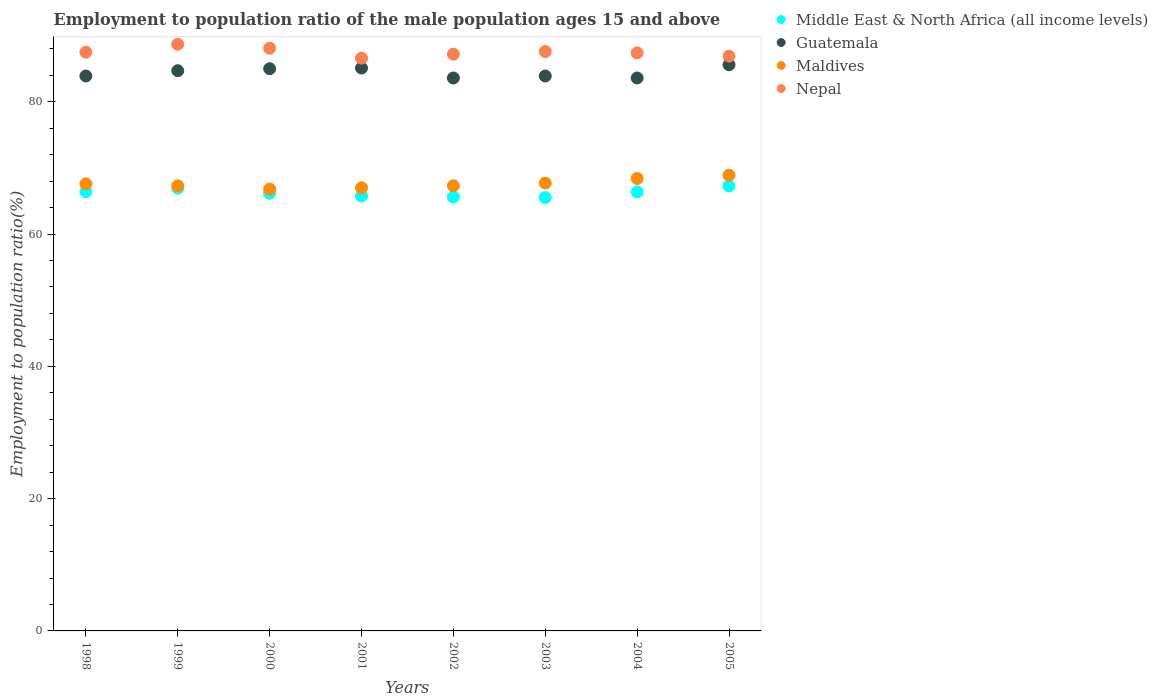Is the number of dotlines equal to the number of legend labels?
Your answer should be compact. Yes. What is the employment to population ratio in Maldives in 2002?
Offer a very short reply. 67.3. Across all years, what is the maximum employment to population ratio in Guatemala?
Offer a very short reply. 85.6. Across all years, what is the minimum employment to population ratio in Nepal?
Give a very brief answer. 86.6. What is the total employment to population ratio in Guatemala in the graph?
Your answer should be compact. 675.4. What is the difference between the employment to population ratio in Middle East & North Africa (all income levels) in 1998 and that in 2000?
Provide a succinct answer. 0.22. What is the difference between the employment to population ratio in Nepal in 2004 and the employment to population ratio in Maldives in 2002?
Offer a terse response. 20.1. What is the average employment to population ratio in Guatemala per year?
Your answer should be compact. 84.42. In the year 2001, what is the difference between the employment to population ratio in Nepal and employment to population ratio in Guatemala?
Your response must be concise. 1.5. In how many years, is the employment to population ratio in Guatemala greater than 4 %?
Ensure brevity in your answer.  8. What is the ratio of the employment to population ratio in Nepal in 2000 to that in 2002?
Provide a succinct answer. 1.01. Is the difference between the employment to population ratio in Nepal in 2000 and 2002 greater than the difference between the employment to population ratio in Guatemala in 2000 and 2002?
Your answer should be very brief. No. What is the difference between the highest and the second highest employment to population ratio in Maldives?
Provide a short and direct response. 0.5. What is the difference between the highest and the lowest employment to population ratio in Middle East & North Africa (all income levels)?
Give a very brief answer. 1.75. Is the sum of the employment to population ratio in Guatemala in 1998 and 1999 greater than the maximum employment to population ratio in Nepal across all years?
Give a very brief answer. Yes. Is it the case that in every year, the sum of the employment to population ratio in Guatemala and employment to population ratio in Middle East & North Africa (all income levels)  is greater than the sum of employment to population ratio in Nepal and employment to population ratio in Maldives?
Offer a terse response. No. Is the employment to population ratio in Middle East & North Africa (all income levels) strictly greater than the employment to population ratio in Nepal over the years?
Your answer should be very brief. No. How many dotlines are there?
Your answer should be very brief. 4. Are the values on the major ticks of Y-axis written in scientific E-notation?
Give a very brief answer. No. Does the graph contain grids?
Offer a terse response. No. How many legend labels are there?
Provide a short and direct response. 4. What is the title of the graph?
Your answer should be compact. Employment to population ratio of the male population ages 15 and above. What is the label or title of the Y-axis?
Give a very brief answer. Employment to population ratio(%). What is the Employment to population ratio(%) of Middle East & North Africa (all income levels) in 1998?
Keep it short and to the point. 66.39. What is the Employment to population ratio(%) of Guatemala in 1998?
Provide a short and direct response. 83.9. What is the Employment to population ratio(%) of Maldives in 1998?
Provide a short and direct response. 67.6. What is the Employment to population ratio(%) of Nepal in 1998?
Make the answer very short. 87.5. What is the Employment to population ratio(%) of Middle East & North Africa (all income levels) in 1999?
Offer a terse response. 66.94. What is the Employment to population ratio(%) of Guatemala in 1999?
Provide a short and direct response. 84.7. What is the Employment to population ratio(%) in Maldives in 1999?
Provide a short and direct response. 67.3. What is the Employment to population ratio(%) in Nepal in 1999?
Your response must be concise. 88.7. What is the Employment to population ratio(%) in Middle East & North Africa (all income levels) in 2000?
Provide a short and direct response. 66.17. What is the Employment to population ratio(%) in Maldives in 2000?
Your response must be concise. 66.8. What is the Employment to population ratio(%) in Nepal in 2000?
Make the answer very short. 88.1. What is the Employment to population ratio(%) in Middle East & North Africa (all income levels) in 2001?
Keep it short and to the point. 65.75. What is the Employment to population ratio(%) in Guatemala in 2001?
Offer a very short reply. 85.1. What is the Employment to population ratio(%) in Maldives in 2001?
Your answer should be very brief. 67. What is the Employment to population ratio(%) in Nepal in 2001?
Ensure brevity in your answer.  86.6. What is the Employment to population ratio(%) of Middle East & North Africa (all income levels) in 2002?
Keep it short and to the point. 65.6. What is the Employment to population ratio(%) of Guatemala in 2002?
Keep it short and to the point. 83.6. What is the Employment to population ratio(%) in Maldives in 2002?
Your answer should be compact. 67.3. What is the Employment to population ratio(%) of Nepal in 2002?
Offer a very short reply. 87.2. What is the Employment to population ratio(%) in Middle East & North Africa (all income levels) in 2003?
Offer a very short reply. 65.53. What is the Employment to population ratio(%) of Guatemala in 2003?
Your answer should be compact. 83.9. What is the Employment to population ratio(%) in Maldives in 2003?
Keep it short and to the point. 67.7. What is the Employment to population ratio(%) in Nepal in 2003?
Offer a very short reply. 87.6. What is the Employment to population ratio(%) in Middle East & North Africa (all income levels) in 2004?
Provide a short and direct response. 66.37. What is the Employment to population ratio(%) of Guatemala in 2004?
Offer a very short reply. 83.6. What is the Employment to population ratio(%) of Maldives in 2004?
Provide a succinct answer. 68.4. What is the Employment to population ratio(%) in Nepal in 2004?
Your response must be concise. 87.4. What is the Employment to population ratio(%) of Middle East & North Africa (all income levels) in 2005?
Offer a terse response. 67.28. What is the Employment to population ratio(%) of Guatemala in 2005?
Your response must be concise. 85.6. What is the Employment to population ratio(%) of Maldives in 2005?
Make the answer very short. 68.9. What is the Employment to population ratio(%) in Nepal in 2005?
Your response must be concise. 86.9. Across all years, what is the maximum Employment to population ratio(%) in Middle East & North Africa (all income levels)?
Provide a short and direct response. 67.28. Across all years, what is the maximum Employment to population ratio(%) in Guatemala?
Provide a short and direct response. 85.6. Across all years, what is the maximum Employment to population ratio(%) of Maldives?
Provide a succinct answer. 68.9. Across all years, what is the maximum Employment to population ratio(%) in Nepal?
Provide a succinct answer. 88.7. Across all years, what is the minimum Employment to population ratio(%) in Middle East & North Africa (all income levels)?
Provide a succinct answer. 65.53. Across all years, what is the minimum Employment to population ratio(%) in Guatemala?
Your response must be concise. 83.6. Across all years, what is the minimum Employment to population ratio(%) of Maldives?
Ensure brevity in your answer.  66.8. Across all years, what is the minimum Employment to population ratio(%) in Nepal?
Keep it short and to the point. 86.6. What is the total Employment to population ratio(%) in Middle East & North Africa (all income levels) in the graph?
Ensure brevity in your answer.  530.03. What is the total Employment to population ratio(%) in Guatemala in the graph?
Provide a short and direct response. 675.4. What is the total Employment to population ratio(%) of Maldives in the graph?
Ensure brevity in your answer.  541. What is the total Employment to population ratio(%) in Nepal in the graph?
Keep it short and to the point. 700. What is the difference between the Employment to population ratio(%) of Middle East & North Africa (all income levels) in 1998 and that in 1999?
Your answer should be very brief. -0.54. What is the difference between the Employment to population ratio(%) of Guatemala in 1998 and that in 1999?
Keep it short and to the point. -0.8. What is the difference between the Employment to population ratio(%) of Maldives in 1998 and that in 1999?
Keep it short and to the point. 0.3. What is the difference between the Employment to population ratio(%) in Middle East & North Africa (all income levels) in 1998 and that in 2000?
Your answer should be compact. 0.22. What is the difference between the Employment to population ratio(%) of Guatemala in 1998 and that in 2000?
Provide a short and direct response. -1.1. What is the difference between the Employment to population ratio(%) in Middle East & North Africa (all income levels) in 1998 and that in 2001?
Provide a short and direct response. 0.64. What is the difference between the Employment to population ratio(%) in Middle East & North Africa (all income levels) in 1998 and that in 2002?
Ensure brevity in your answer.  0.79. What is the difference between the Employment to population ratio(%) of Nepal in 1998 and that in 2002?
Your answer should be very brief. 0.3. What is the difference between the Employment to population ratio(%) of Middle East & North Africa (all income levels) in 1998 and that in 2003?
Offer a very short reply. 0.86. What is the difference between the Employment to population ratio(%) in Maldives in 1998 and that in 2003?
Offer a terse response. -0.1. What is the difference between the Employment to population ratio(%) in Nepal in 1998 and that in 2003?
Your answer should be compact. -0.1. What is the difference between the Employment to population ratio(%) of Middle East & North Africa (all income levels) in 1998 and that in 2004?
Offer a terse response. 0.03. What is the difference between the Employment to population ratio(%) in Maldives in 1998 and that in 2004?
Give a very brief answer. -0.8. What is the difference between the Employment to population ratio(%) in Nepal in 1998 and that in 2004?
Keep it short and to the point. 0.1. What is the difference between the Employment to population ratio(%) in Middle East & North Africa (all income levels) in 1998 and that in 2005?
Provide a short and direct response. -0.89. What is the difference between the Employment to population ratio(%) in Maldives in 1998 and that in 2005?
Provide a short and direct response. -1.3. What is the difference between the Employment to population ratio(%) of Nepal in 1998 and that in 2005?
Your answer should be very brief. 0.6. What is the difference between the Employment to population ratio(%) in Middle East & North Africa (all income levels) in 1999 and that in 2000?
Your answer should be compact. 0.77. What is the difference between the Employment to population ratio(%) in Middle East & North Africa (all income levels) in 1999 and that in 2001?
Provide a succinct answer. 1.18. What is the difference between the Employment to population ratio(%) in Nepal in 1999 and that in 2001?
Your response must be concise. 2.1. What is the difference between the Employment to population ratio(%) in Middle East & North Africa (all income levels) in 1999 and that in 2002?
Offer a very short reply. 1.33. What is the difference between the Employment to population ratio(%) in Guatemala in 1999 and that in 2002?
Ensure brevity in your answer.  1.1. What is the difference between the Employment to population ratio(%) in Middle East & North Africa (all income levels) in 1999 and that in 2003?
Your answer should be compact. 1.41. What is the difference between the Employment to population ratio(%) of Middle East & North Africa (all income levels) in 1999 and that in 2004?
Your response must be concise. 0.57. What is the difference between the Employment to population ratio(%) of Guatemala in 1999 and that in 2004?
Offer a very short reply. 1.1. What is the difference between the Employment to population ratio(%) of Maldives in 1999 and that in 2004?
Your answer should be compact. -1.1. What is the difference between the Employment to population ratio(%) in Nepal in 1999 and that in 2004?
Offer a terse response. 1.3. What is the difference between the Employment to population ratio(%) in Middle East & North Africa (all income levels) in 1999 and that in 2005?
Your response must be concise. -0.34. What is the difference between the Employment to population ratio(%) of Guatemala in 1999 and that in 2005?
Give a very brief answer. -0.9. What is the difference between the Employment to population ratio(%) in Maldives in 1999 and that in 2005?
Your response must be concise. -1.6. What is the difference between the Employment to population ratio(%) in Nepal in 1999 and that in 2005?
Provide a succinct answer. 1.8. What is the difference between the Employment to population ratio(%) in Middle East & North Africa (all income levels) in 2000 and that in 2001?
Keep it short and to the point. 0.41. What is the difference between the Employment to population ratio(%) of Nepal in 2000 and that in 2001?
Ensure brevity in your answer.  1.5. What is the difference between the Employment to population ratio(%) of Middle East & North Africa (all income levels) in 2000 and that in 2002?
Provide a short and direct response. 0.56. What is the difference between the Employment to population ratio(%) in Middle East & North Africa (all income levels) in 2000 and that in 2003?
Provide a short and direct response. 0.64. What is the difference between the Employment to population ratio(%) in Guatemala in 2000 and that in 2003?
Ensure brevity in your answer.  1.1. What is the difference between the Employment to population ratio(%) of Maldives in 2000 and that in 2003?
Make the answer very short. -0.9. What is the difference between the Employment to population ratio(%) of Middle East & North Africa (all income levels) in 2000 and that in 2004?
Give a very brief answer. -0.2. What is the difference between the Employment to population ratio(%) of Guatemala in 2000 and that in 2004?
Your answer should be compact. 1.4. What is the difference between the Employment to population ratio(%) of Maldives in 2000 and that in 2004?
Provide a short and direct response. -1.6. What is the difference between the Employment to population ratio(%) of Nepal in 2000 and that in 2004?
Your response must be concise. 0.7. What is the difference between the Employment to population ratio(%) in Middle East & North Africa (all income levels) in 2000 and that in 2005?
Offer a very short reply. -1.11. What is the difference between the Employment to population ratio(%) in Nepal in 2000 and that in 2005?
Offer a terse response. 1.2. What is the difference between the Employment to population ratio(%) of Middle East & North Africa (all income levels) in 2001 and that in 2002?
Ensure brevity in your answer.  0.15. What is the difference between the Employment to population ratio(%) of Maldives in 2001 and that in 2002?
Provide a succinct answer. -0.3. What is the difference between the Employment to population ratio(%) of Nepal in 2001 and that in 2002?
Keep it short and to the point. -0.6. What is the difference between the Employment to population ratio(%) of Middle East & North Africa (all income levels) in 2001 and that in 2003?
Make the answer very short. 0.22. What is the difference between the Employment to population ratio(%) of Guatemala in 2001 and that in 2003?
Offer a terse response. 1.2. What is the difference between the Employment to population ratio(%) of Nepal in 2001 and that in 2003?
Your answer should be compact. -1. What is the difference between the Employment to population ratio(%) in Middle East & North Africa (all income levels) in 2001 and that in 2004?
Offer a terse response. -0.61. What is the difference between the Employment to population ratio(%) of Guatemala in 2001 and that in 2004?
Provide a succinct answer. 1.5. What is the difference between the Employment to population ratio(%) of Nepal in 2001 and that in 2004?
Your answer should be compact. -0.8. What is the difference between the Employment to population ratio(%) in Middle East & North Africa (all income levels) in 2001 and that in 2005?
Give a very brief answer. -1.53. What is the difference between the Employment to population ratio(%) in Maldives in 2001 and that in 2005?
Offer a terse response. -1.9. What is the difference between the Employment to population ratio(%) of Middle East & North Africa (all income levels) in 2002 and that in 2003?
Ensure brevity in your answer.  0.08. What is the difference between the Employment to population ratio(%) in Middle East & North Africa (all income levels) in 2002 and that in 2004?
Ensure brevity in your answer.  -0.76. What is the difference between the Employment to population ratio(%) in Maldives in 2002 and that in 2004?
Keep it short and to the point. -1.1. What is the difference between the Employment to population ratio(%) in Nepal in 2002 and that in 2004?
Provide a succinct answer. -0.2. What is the difference between the Employment to population ratio(%) of Middle East & North Africa (all income levels) in 2002 and that in 2005?
Ensure brevity in your answer.  -1.67. What is the difference between the Employment to population ratio(%) in Guatemala in 2002 and that in 2005?
Offer a terse response. -2. What is the difference between the Employment to population ratio(%) of Middle East & North Africa (all income levels) in 2003 and that in 2004?
Keep it short and to the point. -0.84. What is the difference between the Employment to population ratio(%) in Middle East & North Africa (all income levels) in 2003 and that in 2005?
Provide a succinct answer. -1.75. What is the difference between the Employment to population ratio(%) in Guatemala in 2003 and that in 2005?
Give a very brief answer. -1.7. What is the difference between the Employment to population ratio(%) in Nepal in 2003 and that in 2005?
Provide a short and direct response. 0.7. What is the difference between the Employment to population ratio(%) in Middle East & North Africa (all income levels) in 2004 and that in 2005?
Your answer should be very brief. -0.91. What is the difference between the Employment to population ratio(%) of Guatemala in 2004 and that in 2005?
Offer a terse response. -2. What is the difference between the Employment to population ratio(%) in Maldives in 2004 and that in 2005?
Offer a terse response. -0.5. What is the difference between the Employment to population ratio(%) of Middle East & North Africa (all income levels) in 1998 and the Employment to population ratio(%) of Guatemala in 1999?
Ensure brevity in your answer.  -18.31. What is the difference between the Employment to population ratio(%) in Middle East & North Africa (all income levels) in 1998 and the Employment to population ratio(%) in Maldives in 1999?
Ensure brevity in your answer.  -0.91. What is the difference between the Employment to population ratio(%) in Middle East & North Africa (all income levels) in 1998 and the Employment to population ratio(%) in Nepal in 1999?
Offer a very short reply. -22.31. What is the difference between the Employment to population ratio(%) of Guatemala in 1998 and the Employment to population ratio(%) of Maldives in 1999?
Provide a short and direct response. 16.6. What is the difference between the Employment to population ratio(%) of Maldives in 1998 and the Employment to population ratio(%) of Nepal in 1999?
Make the answer very short. -21.1. What is the difference between the Employment to population ratio(%) in Middle East & North Africa (all income levels) in 1998 and the Employment to population ratio(%) in Guatemala in 2000?
Offer a terse response. -18.61. What is the difference between the Employment to population ratio(%) in Middle East & North Africa (all income levels) in 1998 and the Employment to population ratio(%) in Maldives in 2000?
Your answer should be compact. -0.41. What is the difference between the Employment to population ratio(%) in Middle East & North Africa (all income levels) in 1998 and the Employment to population ratio(%) in Nepal in 2000?
Provide a short and direct response. -21.71. What is the difference between the Employment to population ratio(%) in Guatemala in 1998 and the Employment to population ratio(%) in Maldives in 2000?
Provide a succinct answer. 17.1. What is the difference between the Employment to population ratio(%) in Guatemala in 1998 and the Employment to population ratio(%) in Nepal in 2000?
Provide a succinct answer. -4.2. What is the difference between the Employment to population ratio(%) of Maldives in 1998 and the Employment to population ratio(%) of Nepal in 2000?
Offer a terse response. -20.5. What is the difference between the Employment to population ratio(%) in Middle East & North Africa (all income levels) in 1998 and the Employment to population ratio(%) in Guatemala in 2001?
Keep it short and to the point. -18.71. What is the difference between the Employment to population ratio(%) in Middle East & North Africa (all income levels) in 1998 and the Employment to population ratio(%) in Maldives in 2001?
Provide a short and direct response. -0.61. What is the difference between the Employment to population ratio(%) in Middle East & North Africa (all income levels) in 1998 and the Employment to population ratio(%) in Nepal in 2001?
Make the answer very short. -20.21. What is the difference between the Employment to population ratio(%) of Middle East & North Africa (all income levels) in 1998 and the Employment to population ratio(%) of Guatemala in 2002?
Offer a very short reply. -17.21. What is the difference between the Employment to population ratio(%) in Middle East & North Africa (all income levels) in 1998 and the Employment to population ratio(%) in Maldives in 2002?
Offer a very short reply. -0.91. What is the difference between the Employment to population ratio(%) in Middle East & North Africa (all income levels) in 1998 and the Employment to population ratio(%) in Nepal in 2002?
Your answer should be very brief. -20.81. What is the difference between the Employment to population ratio(%) in Guatemala in 1998 and the Employment to population ratio(%) in Maldives in 2002?
Offer a very short reply. 16.6. What is the difference between the Employment to population ratio(%) in Guatemala in 1998 and the Employment to population ratio(%) in Nepal in 2002?
Provide a succinct answer. -3.3. What is the difference between the Employment to population ratio(%) of Maldives in 1998 and the Employment to population ratio(%) of Nepal in 2002?
Make the answer very short. -19.6. What is the difference between the Employment to population ratio(%) of Middle East & North Africa (all income levels) in 1998 and the Employment to population ratio(%) of Guatemala in 2003?
Keep it short and to the point. -17.51. What is the difference between the Employment to population ratio(%) of Middle East & North Africa (all income levels) in 1998 and the Employment to population ratio(%) of Maldives in 2003?
Your answer should be very brief. -1.31. What is the difference between the Employment to population ratio(%) in Middle East & North Africa (all income levels) in 1998 and the Employment to population ratio(%) in Nepal in 2003?
Give a very brief answer. -21.21. What is the difference between the Employment to population ratio(%) in Guatemala in 1998 and the Employment to population ratio(%) in Maldives in 2003?
Your response must be concise. 16.2. What is the difference between the Employment to population ratio(%) of Maldives in 1998 and the Employment to population ratio(%) of Nepal in 2003?
Provide a succinct answer. -20. What is the difference between the Employment to population ratio(%) of Middle East & North Africa (all income levels) in 1998 and the Employment to population ratio(%) of Guatemala in 2004?
Make the answer very short. -17.21. What is the difference between the Employment to population ratio(%) in Middle East & North Africa (all income levels) in 1998 and the Employment to population ratio(%) in Maldives in 2004?
Make the answer very short. -2.01. What is the difference between the Employment to population ratio(%) in Middle East & North Africa (all income levels) in 1998 and the Employment to population ratio(%) in Nepal in 2004?
Your response must be concise. -21.01. What is the difference between the Employment to population ratio(%) of Maldives in 1998 and the Employment to population ratio(%) of Nepal in 2004?
Your response must be concise. -19.8. What is the difference between the Employment to population ratio(%) in Middle East & North Africa (all income levels) in 1998 and the Employment to population ratio(%) in Guatemala in 2005?
Keep it short and to the point. -19.21. What is the difference between the Employment to population ratio(%) of Middle East & North Africa (all income levels) in 1998 and the Employment to population ratio(%) of Maldives in 2005?
Provide a succinct answer. -2.51. What is the difference between the Employment to population ratio(%) in Middle East & North Africa (all income levels) in 1998 and the Employment to population ratio(%) in Nepal in 2005?
Keep it short and to the point. -20.51. What is the difference between the Employment to population ratio(%) of Guatemala in 1998 and the Employment to population ratio(%) of Maldives in 2005?
Offer a very short reply. 15. What is the difference between the Employment to population ratio(%) in Maldives in 1998 and the Employment to population ratio(%) in Nepal in 2005?
Provide a short and direct response. -19.3. What is the difference between the Employment to population ratio(%) in Middle East & North Africa (all income levels) in 1999 and the Employment to population ratio(%) in Guatemala in 2000?
Your response must be concise. -18.06. What is the difference between the Employment to population ratio(%) in Middle East & North Africa (all income levels) in 1999 and the Employment to population ratio(%) in Maldives in 2000?
Ensure brevity in your answer.  0.14. What is the difference between the Employment to population ratio(%) in Middle East & North Africa (all income levels) in 1999 and the Employment to population ratio(%) in Nepal in 2000?
Give a very brief answer. -21.16. What is the difference between the Employment to population ratio(%) in Guatemala in 1999 and the Employment to population ratio(%) in Nepal in 2000?
Provide a short and direct response. -3.4. What is the difference between the Employment to population ratio(%) of Maldives in 1999 and the Employment to population ratio(%) of Nepal in 2000?
Your response must be concise. -20.8. What is the difference between the Employment to population ratio(%) of Middle East & North Africa (all income levels) in 1999 and the Employment to population ratio(%) of Guatemala in 2001?
Your response must be concise. -18.16. What is the difference between the Employment to population ratio(%) in Middle East & North Africa (all income levels) in 1999 and the Employment to population ratio(%) in Maldives in 2001?
Your answer should be very brief. -0.06. What is the difference between the Employment to population ratio(%) of Middle East & North Africa (all income levels) in 1999 and the Employment to population ratio(%) of Nepal in 2001?
Ensure brevity in your answer.  -19.66. What is the difference between the Employment to population ratio(%) of Guatemala in 1999 and the Employment to population ratio(%) of Nepal in 2001?
Your answer should be very brief. -1.9. What is the difference between the Employment to population ratio(%) of Maldives in 1999 and the Employment to population ratio(%) of Nepal in 2001?
Your answer should be very brief. -19.3. What is the difference between the Employment to population ratio(%) of Middle East & North Africa (all income levels) in 1999 and the Employment to population ratio(%) of Guatemala in 2002?
Your response must be concise. -16.66. What is the difference between the Employment to population ratio(%) of Middle East & North Africa (all income levels) in 1999 and the Employment to population ratio(%) of Maldives in 2002?
Your answer should be compact. -0.36. What is the difference between the Employment to population ratio(%) of Middle East & North Africa (all income levels) in 1999 and the Employment to population ratio(%) of Nepal in 2002?
Keep it short and to the point. -20.26. What is the difference between the Employment to population ratio(%) of Guatemala in 1999 and the Employment to population ratio(%) of Maldives in 2002?
Your response must be concise. 17.4. What is the difference between the Employment to population ratio(%) of Maldives in 1999 and the Employment to population ratio(%) of Nepal in 2002?
Keep it short and to the point. -19.9. What is the difference between the Employment to population ratio(%) in Middle East & North Africa (all income levels) in 1999 and the Employment to population ratio(%) in Guatemala in 2003?
Provide a short and direct response. -16.96. What is the difference between the Employment to population ratio(%) of Middle East & North Africa (all income levels) in 1999 and the Employment to population ratio(%) of Maldives in 2003?
Your response must be concise. -0.76. What is the difference between the Employment to population ratio(%) in Middle East & North Africa (all income levels) in 1999 and the Employment to population ratio(%) in Nepal in 2003?
Your answer should be compact. -20.66. What is the difference between the Employment to population ratio(%) in Guatemala in 1999 and the Employment to population ratio(%) in Maldives in 2003?
Ensure brevity in your answer.  17. What is the difference between the Employment to population ratio(%) of Guatemala in 1999 and the Employment to population ratio(%) of Nepal in 2003?
Provide a short and direct response. -2.9. What is the difference between the Employment to population ratio(%) of Maldives in 1999 and the Employment to population ratio(%) of Nepal in 2003?
Ensure brevity in your answer.  -20.3. What is the difference between the Employment to population ratio(%) of Middle East & North Africa (all income levels) in 1999 and the Employment to population ratio(%) of Guatemala in 2004?
Offer a terse response. -16.66. What is the difference between the Employment to population ratio(%) in Middle East & North Africa (all income levels) in 1999 and the Employment to population ratio(%) in Maldives in 2004?
Give a very brief answer. -1.46. What is the difference between the Employment to population ratio(%) of Middle East & North Africa (all income levels) in 1999 and the Employment to population ratio(%) of Nepal in 2004?
Ensure brevity in your answer.  -20.46. What is the difference between the Employment to population ratio(%) of Guatemala in 1999 and the Employment to population ratio(%) of Nepal in 2004?
Ensure brevity in your answer.  -2.7. What is the difference between the Employment to population ratio(%) of Maldives in 1999 and the Employment to population ratio(%) of Nepal in 2004?
Provide a succinct answer. -20.1. What is the difference between the Employment to population ratio(%) of Middle East & North Africa (all income levels) in 1999 and the Employment to population ratio(%) of Guatemala in 2005?
Provide a short and direct response. -18.66. What is the difference between the Employment to population ratio(%) of Middle East & North Africa (all income levels) in 1999 and the Employment to population ratio(%) of Maldives in 2005?
Make the answer very short. -1.96. What is the difference between the Employment to population ratio(%) in Middle East & North Africa (all income levels) in 1999 and the Employment to population ratio(%) in Nepal in 2005?
Offer a very short reply. -19.96. What is the difference between the Employment to population ratio(%) in Guatemala in 1999 and the Employment to population ratio(%) in Nepal in 2005?
Your answer should be compact. -2.2. What is the difference between the Employment to population ratio(%) in Maldives in 1999 and the Employment to population ratio(%) in Nepal in 2005?
Make the answer very short. -19.6. What is the difference between the Employment to population ratio(%) in Middle East & North Africa (all income levels) in 2000 and the Employment to population ratio(%) in Guatemala in 2001?
Ensure brevity in your answer.  -18.93. What is the difference between the Employment to population ratio(%) of Middle East & North Africa (all income levels) in 2000 and the Employment to population ratio(%) of Maldives in 2001?
Offer a very short reply. -0.83. What is the difference between the Employment to population ratio(%) in Middle East & North Africa (all income levels) in 2000 and the Employment to population ratio(%) in Nepal in 2001?
Make the answer very short. -20.43. What is the difference between the Employment to population ratio(%) in Guatemala in 2000 and the Employment to population ratio(%) in Maldives in 2001?
Provide a succinct answer. 18. What is the difference between the Employment to population ratio(%) in Guatemala in 2000 and the Employment to population ratio(%) in Nepal in 2001?
Make the answer very short. -1.6. What is the difference between the Employment to population ratio(%) in Maldives in 2000 and the Employment to population ratio(%) in Nepal in 2001?
Your response must be concise. -19.8. What is the difference between the Employment to population ratio(%) of Middle East & North Africa (all income levels) in 2000 and the Employment to population ratio(%) of Guatemala in 2002?
Your answer should be very brief. -17.43. What is the difference between the Employment to population ratio(%) of Middle East & North Africa (all income levels) in 2000 and the Employment to population ratio(%) of Maldives in 2002?
Your response must be concise. -1.13. What is the difference between the Employment to population ratio(%) of Middle East & North Africa (all income levels) in 2000 and the Employment to population ratio(%) of Nepal in 2002?
Offer a terse response. -21.03. What is the difference between the Employment to population ratio(%) of Guatemala in 2000 and the Employment to population ratio(%) of Maldives in 2002?
Your response must be concise. 17.7. What is the difference between the Employment to population ratio(%) of Maldives in 2000 and the Employment to population ratio(%) of Nepal in 2002?
Give a very brief answer. -20.4. What is the difference between the Employment to population ratio(%) of Middle East & North Africa (all income levels) in 2000 and the Employment to population ratio(%) of Guatemala in 2003?
Offer a very short reply. -17.73. What is the difference between the Employment to population ratio(%) in Middle East & North Africa (all income levels) in 2000 and the Employment to population ratio(%) in Maldives in 2003?
Keep it short and to the point. -1.53. What is the difference between the Employment to population ratio(%) of Middle East & North Africa (all income levels) in 2000 and the Employment to population ratio(%) of Nepal in 2003?
Your answer should be very brief. -21.43. What is the difference between the Employment to population ratio(%) in Guatemala in 2000 and the Employment to population ratio(%) in Maldives in 2003?
Provide a succinct answer. 17.3. What is the difference between the Employment to population ratio(%) of Maldives in 2000 and the Employment to population ratio(%) of Nepal in 2003?
Make the answer very short. -20.8. What is the difference between the Employment to population ratio(%) of Middle East & North Africa (all income levels) in 2000 and the Employment to population ratio(%) of Guatemala in 2004?
Provide a short and direct response. -17.43. What is the difference between the Employment to population ratio(%) in Middle East & North Africa (all income levels) in 2000 and the Employment to population ratio(%) in Maldives in 2004?
Your answer should be compact. -2.23. What is the difference between the Employment to population ratio(%) of Middle East & North Africa (all income levels) in 2000 and the Employment to population ratio(%) of Nepal in 2004?
Offer a terse response. -21.23. What is the difference between the Employment to population ratio(%) of Guatemala in 2000 and the Employment to population ratio(%) of Maldives in 2004?
Give a very brief answer. 16.6. What is the difference between the Employment to population ratio(%) in Guatemala in 2000 and the Employment to population ratio(%) in Nepal in 2004?
Provide a succinct answer. -2.4. What is the difference between the Employment to population ratio(%) of Maldives in 2000 and the Employment to population ratio(%) of Nepal in 2004?
Your answer should be very brief. -20.6. What is the difference between the Employment to population ratio(%) in Middle East & North Africa (all income levels) in 2000 and the Employment to population ratio(%) in Guatemala in 2005?
Ensure brevity in your answer.  -19.43. What is the difference between the Employment to population ratio(%) of Middle East & North Africa (all income levels) in 2000 and the Employment to population ratio(%) of Maldives in 2005?
Provide a succinct answer. -2.73. What is the difference between the Employment to population ratio(%) of Middle East & North Africa (all income levels) in 2000 and the Employment to population ratio(%) of Nepal in 2005?
Ensure brevity in your answer.  -20.73. What is the difference between the Employment to population ratio(%) of Maldives in 2000 and the Employment to population ratio(%) of Nepal in 2005?
Give a very brief answer. -20.1. What is the difference between the Employment to population ratio(%) of Middle East & North Africa (all income levels) in 2001 and the Employment to population ratio(%) of Guatemala in 2002?
Make the answer very short. -17.85. What is the difference between the Employment to population ratio(%) of Middle East & North Africa (all income levels) in 2001 and the Employment to population ratio(%) of Maldives in 2002?
Provide a short and direct response. -1.55. What is the difference between the Employment to population ratio(%) of Middle East & North Africa (all income levels) in 2001 and the Employment to population ratio(%) of Nepal in 2002?
Your answer should be very brief. -21.45. What is the difference between the Employment to population ratio(%) in Guatemala in 2001 and the Employment to population ratio(%) in Maldives in 2002?
Keep it short and to the point. 17.8. What is the difference between the Employment to population ratio(%) in Maldives in 2001 and the Employment to population ratio(%) in Nepal in 2002?
Provide a succinct answer. -20.2. What is the difference between the Employment to population ratio(%) in Middle East & North Africa (all income levels) in 2001 and the Employment to population ratio(%) in Guatemala in 2003?
Your answer should be compact. -18.15. What is the difference between the Employment to population ratio(%) in Middle East & North Africa (all income levels) in 2001 and the Employment to population ratio(%) in Maldives in 2003?
Offer a terse response. -1.95. What is the difference between the Employment to population ratio(%) in Middle East & North Africa (all income levels) in 2001 and the Employment to population ratio(%) in Nepal in 2003?
Keep it short and to the point. -21.85. What is the difference between the Employment to population ratio(%) of Maldives in 2001 and the Employment to population ratio(%) of Nepal in 2003?
Ensure brevity in your answer.  -20.6. What is the difference between the Employment to population ratio(%) of Middle East & North Africa (all income levels) in 2001 and the Employment to population ratio(%) of Guatemala in 2004?
Your answer should be very brief. -17.85. What is the difference between the Employment to population ratio(%) in Middle East & North Africa (all income levels) in 2001 and the Employment to population ratio(%) in Maldives in 2004?
Ensure brevity in your answer.  -2.65. What is the difference between the Employment to population ratio(%) of Middle East & North Africa (all income levels) in 2001 and the Employment to population ratio(%) of Nepal in 2004?
Provide a succinct answer. -21.65. What is the difference between the Employment to population ratio(%) of Guatemala in 2001 and the Employment to population ratio(%) of Maldives in 2004?
Ensure brevity in your answer.  16.7. What is the difference between the Employment to population ratio(%) in Guatemala in 2001 and the Employment to population ratio(%) in Nepal in 2004?
Offer a very short reply. -2.3. What is the difference between the Employment to population ratio(%) of Maldives in 2001 and the Employment to population ratio(%) of Nepal in 2004?
Your answer should be compact. -20.4. What is the difference between the Employment to population ratio(%) in Middle East & North Africa (all income levels) in 2001 and the Employment to population ratio(%) in Guatemala in 2005?
Provide a short and direct response. -19.85. What is the difference between the Employment to population ratio(%) of Middle East & North Africa (all income levels) in 2001 and the Employment to population ratio(%) of Maldives in 2005?
Your response must be concise. -3.15. What is the difference between the Employment to population ratio(%) of Middle East & North Africa (all income levels) in 2001 and the Employment to population ratio(%) of Nepal in 2005?
Provide a succinct answer. -21.15. What is the difference between the Employment to population ratio(%) of Guatemala in 2001 and the Employment to population ratio(%) of Maldives in 2005?
Provide a short and direct response. 16.2. What is the difference between the Employment to population ratio(%) in Maldives in 2001 and the Employment to population ratio(%) in Nepal in 2005?
Provide a succinct answer. -19.9. What is the difference between the Employment to population ratio(%) in Middle East & North Africa (all income levels) in 2002 and the Employment to population ratio(%) in Guatemala in 2003?
Offer a very short reply. -18.3. What is the difference between the Employment to population ratio(%) in Middle East & North Africa (all income levels) in 2002 and the Employment to population ratio(%) in Maldives in 2003?
Provide a short and direct response. -2.1. What is the difference between the Employment to population ratio(%) in Middle East & North Africa (all income levels) in 2002 and the Employment to population ratio(%) in Nepal in 2003?
Your answer should be compact. -22. What is the difference between the Employment to population ratio(%) in Guatemala in 2002 and the Employment to population ratio(%) in Maldives in 2003?
Offer a terse response. 15.9. What is the difference between the Employment to population ratio(%) in Maldives in 2002 and the Employment to population ratio(%) in Nepal in 2003?
Your response must be concise. -20.3. What is the difference between the Employment to population ratio(%) in Middle East & North Africa (all income levels) in 2002 and the Employment to population ratio(%) in Guatemala in 2004?
Offer a terse response. -18. What is the difference between the Employment to population ratio(%) of Middle East & North Africa (all income levels) in 2002 and the Employment to population ratio(%) of Maldives in 2004?
Your response must be concise. -2.8. What is the difference between the Employment to population ratio(%) in Middle East & North Africa (all income levels) in 2002 and the Employment to population ratio(%) in Nepal in 2004?
Your answer should be compact. -21.8. What is the difference between the Employment to population ratio(%) of Guatemala in 2002 and the Employment to population ratio(%) of Nepal in 2004?
Offer a very short reply. -3.8. What is the difference between the Employment to population ratio(%) of Maldives in 2002 and the Employment to population ratio(%) of Nepal in 2004?
Your answer should be very brief. -20.1. What is the difference between the Employment to population ratio(%) in Middle East & North Africa (all income levels) in 2002 and the Employment to population ratio(%) in Guatemala in 2005?
Ensure brevity in your answer.  -20. What is the difference between the Employment to population ratio(%) in Middle East & North Africa (all income levels) in 2002 and the Employment to population ratio(%) in Maldives in 2005?
Provide a short and direct response. -3.3. What is the difference between the Employment to population ratio(%) in Middle East & North Africa (all income levels) in 2002 and the Employment to population ratio(%) in Nepal in 2005?
Provide a succinct answer. -21.3. What is the difference between the Employment to population ratio(%) in Guatemala in 2002 and the Employment to population ratio(%) in Maldives in 2005?
Your answer should be compact. 14.7. What is the difference between the Employment to population ratio(%) in Maldives in 2002 and the Employment to population ratio(%) in Nepal in 2005?
Keep it short and to the point. -19.6. What is the difference between the Employment to population ratio(%) of Middle East & North Africa (all income levels) in 2003 and the Employment to population ratio(%) of Guatemala in 2004?
Offer a terse response. -18.07. What is the difference between the Employment to population ratio(%) of Middle East & North Africa (all income levels) in 2003 and the Employment to population ratio(%) of Maldives in 2004?
Provide a succinct answer. -2.87. What is the difference between the Employment to population ratio(%) in Middle East & North Africa (all income levels) in 2003 and the Employment to population ratio(%) in Nepal in 2004?
Ensure brevity in your answer.  -21.87. What is the difference between the Employment to population ratio(%) of Guatemala in 2003 and the Employment to population ratio(%) of Maldives in 2004?
Your answer should be compact. 15.5. What is the difference between the Employment to population ratio(%) in Maldives in 2003 and the Employment to population ratio(%) in Nepal in 2004?
Your answer should be very brief. -19.7. What is the difference between the Employment to population ratio(%) of Middle East & North Africa (all income levels) in 2003 and the Employment to population ratio(%) of Guatemala in 2005?
Keep it short and to the point. -20.07. What is the difference between the Employment to population ratio(%) of Middle East & North Africa (all income levels) in 2003 and the Employment to population ratio(%) of Maldives in 2005?
Give a very brief answer. -3.37. What is the difference between the Employment to population ratio(%) in Middle East & North Africa (all income levels) in 2003 and the Employment to population ratio(%) in Nepal in 2005?
Offer a very short reply. -21.37. What is the difference between the Employment to population ratio(%) of Guatemala in 2003 and the Employment to population ratio(%) of Nepal in 2005?
Your answer should be very brief. -3. What is the difference between the Employment to population ratio(%) of Maldives in 2003 and the Employment to population ratio(%) of Nepal in 2005?
Your answer should be very brief. -19.2. What is the difference between the Employment to population ratio(%) in Middle East & North Africa (all income levels) in 2004 and the Employment to population ratio(%) in Guatemala in 2005?
Ensure brevity in your answer.  -19.23. What is the difference between the Employment to population ratio(%) in Middle East & North Africa (all income levels) in 2004 and the Employment to population ratio(%) in Maldives in 2005?
Make the answer very short. -2.53. What is the difference between the Employment to population ratio(%) in Middle East & North Africa (all income levels) in 2004 and the Employment to population ratio(%) in Nepal in 2005?
Your response must be concise. -20.53. What is the difference between the Employment to population ratio(%) in Guatemala in 2004 and the Employment to population ratio(%) in Maldives in 2005?
Make the answer very short. 14.7. What is the difference between the Employment to population ratio(%) in Guatemala in 2004 and the Employment to population ratio(%) in Nepal in 2005?
Your answer should be compact. -3.3. What is the difference between the Employment to population ratio(%) in Maldives in 2004 and the Employment to population ratio(%) in Nepal in 2005?
Ensure brevity in your answer.  -18.5. What is the average Employment to population ratio(%) in Middle East & North Africa (all income levels) per year?
Offer a terse response. 66.25. What is the average Employment to population ratio(%) of Guatemala per year?
Your response must be concise. 84.42. What is the average Employment to population ratio(%) in Maldives per year?
Ensure brevity in your answer.  67.62. What is the average Employment to population ratio(%) of Nepal per year?
Your answer should be very brief. 87.5. In the year 1998, what is the difference between the Employment to population ratio(%) in Middle East & North Africa (all income levels) and Employment to population ratio(%) in Guatemala?
Your response must be concise. -17.51. In the year 1998, what is the difference between the Employment to population ratio(%) of Middle East & North Africa (all income levels) and Employment to population ratio(%) of Maldives?
Your answer should be compact. -1.21. In the year 1998, what is the difference between the Employment to population ratio(%) in Middle East & North Africa (all income levels) and Employment to population ratio(%) in Nepal?
Your response must be concise. -21.11. In the year 1998, what is the difference between the Employment to population ratio(%) of Guatemala and Employment to population ratio(%) of Maldives?
Your response must be concise. 16.3. In the year 1998, what is the difference between the Employment to population ratio(%) of Guatemala and Employment to population ratio(%) of Nepal?
Ensure brevity in your answer.  -3.6. In the year 1998, what is the difference between the Employment to population ratio(%) of Maldives and Employment to population ratio(%) of Nepal?
Give a very brief answer. -19.9. In the year 1999, what is the difference between the Employment to population ratio(%) of Middle East & North Africa (all income levels) and Employment to population ratio(%) of Guatemala?
Make the answer very short. -17.76. In the year 1999, what is the difference between the Employment to population ratio(%) in Middle East & North Africa (all income levels) and Employment to population ratio(%) in Maldives?
Your answer should be compact. -0.36. In the year 1999, what is the difference between the Employment to population ratio(%) of Middle East & North Africa (all income levels) and Employment to population ratio(%) of Nepal?
Keep it short and to the point. -21.76. In the year 1999, what is the difference between the Employment to population ratio(%) of Guatemala and Employment to population ratio(%) of Maldives?
Your answer should be compact. 17.4. In the year 1999, what is the difference between the Employment to population ratio(%) of Maldives and Employment to population ratio(%) of Nepal?
Ensure brevity in your answer.  -21.4. In the year 2000, what is the difference between the Employment to population ratio(%) in Middle East & North Africa (all income levels) and Employment to population ratio(%) in Guatemala?
Your answer should be compact. -18.83. In the year 2000, what is the difference between the Employment to population ratio(%) of Middle East & North Africa (all income levels) and Employment to population ratio(%) of Maldives?
Provide a short and direct response. -0.63. In the year 2000, what is the difference between the Employment to population ratio(%) in Middle East & North Africa (all income levels) and Employment to population ratio(%) in Nepal?
Provide a short and direct response. -21.93. In the year 2000, what is the difference between the Employment to population ratio(%) in Guatemala and Employment to population ratio(%) in Nepal?
Ensure brevity in your answer.  -3.1. In the year 2000, what is the difference between the Employment to population ratio(%) of Maldives and Employment to population ratio(%) of Nepal?
Offer a terse response. -21.3. In the year 2001, what is the difference between the Employment to population ratio(%) in Middle East & North Africa (all income levels) and Employment to population ratio(%) in Guatemala?
Offer a very short reply. -19.35. In the year 2001, what is the difference between the Employment to population ratio(%) in Middle East & North Africa (all income levels) and Employment to population ratio(%) in Maldives?
Your answer should be compact. -1.25. In the year 2001, what is the difference between the Employment to population ratio(%) of Middle East & North Africa (all income levels) and Employment to population ratio(%) of Nepal?
Offer a terse response. -20.85. In the year 2001, what is the difference between the Employment to population ratio(%) in Guatemala and Employment to population ratio(%) in Nepal?
Offer a very short reply. -1.5. In the year 2001, what is the difference between the Employment to population ratio(%) of Maldives and Employment to population ratio(%) of Nepal?
Make the answer very short. -19.6. In the year 2002, what is the difference between the Employment to population ratio(%) of Middle East & North Africa (all income levels) and Employment to population ratio(%) of Guatemala?
Your response must be concise. -18. In the year 2002, what is the difference between the Employment to population ratio(%) of Middle East & North Africa (all income levels) and Employment to population ratio(%) of Maldives?
Your answer should be very brief. -1.7. In the year 2002, what is the difference between the Employment to population ratio(%) of Middle East & North Africa (all income levels) and Employment to population ratio(%) of Nepal?
Your answer should be compact. -21.6. In the year 2002, what is the difference between the Employment to population ratio(%) of Guatemala and Employment to population ratio(%) of Nepal?
Keep it short and to the point. -3.6. In the year 2002, what is the difference between the Employment to population ratio(%) of Maldives and Employment to population ratio(%) of Nepal?
Offer a very short reply. -19.9. In the year 2003, what is the difference between the Employment to population ratio(%) of Middle East & North Africa (all income levels) and Employment to population ratio(%) of Guatemala?
Provide a short and direct response. -18.37. In the year 2003, what is the difference between the Employment to population ratio(%) in Middle East & North Africa (all income levels) and Employment to population ratio(%) in Maldives?
Your answer should be very brief. -2.17. In the year 2003, what is the difference between the Employment to population ratio(%) in Middle East & North Africa (all income levels) and Employment to population ratio(%) in Nepal?
Give a very brief answer. -22.07. In the year 2003, what is the difference between the Employment to population ratio(%) of Maldives and Employment to population ratio(%) of Nepal?
Your answer should be very brief. -19.9. In the year 2004, what is the difference between the Employment to population ratio(%) in Middle East & North Africa (all income levels) and Employment to population ratio(%) in Guatemala?
Ensure brevity in your answer.  -17.23. In the year 2004, what is the difference between the Employment to population ratio(%) in Middle East & North Africa (all income levels) and Employment to population ratio(%) in Maldives?
Offer a very short reply. -2.03. In the year 2004, what is the difference between the Employment to population ratio(%) in Middle East & North Africa (all income levels) and Employment to population ratio(%) in Nepal?
Make the answer very short. -21.03. In the year 2004, what is the difference between the Employment to population ratio(%) of Guatemala and Employment to population ratio(%) of Maldives?
Offer a terse response. 15.2. In the year 2004, what is the difference between the Employment to population ratio(%) in Guatemala and Employment to population ratio(%) in Nepal?
Give a very brief answer. -3.8. In the year 2005, what is the difference between the Employment to population ratio(%) in Middle East & North Africa (all income levels) and Employment to population ratio(%) in Guatemala?
Your answer should be compact. -18.32. In the year 2005, what is the difference between the Employment to population ratio(%) in Middle East & North Africa (all income levels) and Employment to population ratio(%) in Maldives?
Keep it short and to the point. -1.62. In the year 2005, what is the difference between the Employment to population ratio(%) of Middle East & North Africa (all income levels) and Employment to population ratio(%) of Nepal?
Provide a succinct answer. -19.62. In the year 2005, what is the difference between the Employment to population ratio(%) in Guatemala and Employment to population ratio(%) in Maldives?
Offer a very short reply. 16.7. In the year 2005, what is the difference between the Employment to population ratio(%) of Guatemala and Employment to population ratio(%) of Nepal?
Your response must be concise. -1.3. In the year 2005, what is the difference between the Employment to population ratio(%) of Maldives and Employment to population ratio(%) of Nepal?
Provide a short and direct response. -18. What is the ratio of the Employment to population ratio(%) in Middle East & North Africa (all income levels) in 1998 to that in 1999?
Your response must be concise. 0.99. What is the ratio of the Employment to population ratio(%) of Guatemala in 1998 to that in 1999?
Ensure brevity in your answer.  0.99. What is the ratio of the Employment to population ratio(%) of Nepal in 1998 to that in 1999?
Make the answer very short. 0.99. What is the ratio of the Employment to population ratio(%) in Guatemala in 1998 to that in 2000?
Offer a terse response. 0.99. What is the ratio of the Employment to population ratio(%) of Middle East & North Africa (all income levels) in 1998 to that in 2001?
Ensure brevity in your answer.  1.01. What is the ratio of the Employment to population ratio(%) in Guatemala in 1998 to that in 2001?
Keep it short and to the point. 0.99. What is the ratio of the Employment to population ratio(%) in Maldives in 1998 to that in 2001?
Offer a terse response. 1.01. What is the ratio of the Employment to population ratio(%) of Nepal in 1998 to that in 2001?
Provide a succinct answer. 1.01. What is the ratio of the Employment to population ratio(%) of Nepal in 1998 to that in 2002?
Keep it short and to the point. 1. What is the ratio of the Employment to population ratio(%) of Middle East & North Africa (all income levels) in 1998 to that in 2003?
Make the answer very short. 1.01. What is the ratio of the Employment to population ratio(%) in Guatemala in 1998 to that in 2003?
Your response must be concise. 1. What is the ratio of the Employment to population ratio(%) of Nepal in 1998 to that in 2003?
Give a very brief answer. 1. What is the ratio of the Employment to population ratio(%) of Guatemala in 1998 to that in 2004?
Your response must be concise. 1. What is the ratio of the Employment to population ratio(%) of Maldives in 1998 to that in 2004?
Your response must be concise. 0.99. What is the ratio of the Employment to population ratio(%) of Nepal in 1998 to that in 2004?
Offer a terse response. 1. What is the ratio of the Employment to population ratio(%) in Guatemala in 1998 to that in 2005?
Your answer should be very brief. 0.98. What is the ratio of the Employment to population ratio(%) of Maldives in 1998 to that in 2005?
Provide a succinct answer. 0.98. What is the ratio of the Employment to population ratio(%) of Nepal in 1998 to that in 2005?
Your response must be concise. 1.01. What is the ratio of the Employment to population ratio(%) of Middle East & North Africa (all income levels) in 1999 to that in 2000?
Give a very brief answer. 1.01. What is the ratio of the Employment to population ratio(%) of Guatemala in 1999 to that in 2000?
Provide a succinct answer. 1. What is the ratio of the Employment to population ratio(%) of Maldives in 1999 to that in 2000?
Provide a succinct answer. 1.01. What is the ratio of the Employment to population ratio(%) of Nepal in 1999 to that in 2000?
Offer a very short reply. 1.01. What is the ratio of the Employment to population ratio(%) in Guatemala in 1999 to that in 2001?
Your answer should be very brief. 1. What is the ratio of the Employment to population ratio(%) in Maldives in 1999 to that in 2001?
Your answer should be compact. 1. What is the ratio of the Employment to population ratio(%) of Nepal in 1999 to that in 2001?
Offer a very short reply. 1.02. What is the ratio of the Employment to population ratio(%) in Middle East & North Africa (all income levels) in 1999 to that in 2002?
Your answer should be very brief. 1.02. What is the ratio of the Employment to population ratio(%) in Guatemala in 1999 to that in 2002?
Offer a terse response. 1.01. What is the ratio of the Employment to population ratio(%) of Maldives in 1999 to that in 2002?
Your response must be concise. 1. What is the ratio of the Employment to population ratio(%) in Nepal in 1999 to that in 2002?
Your answer should be very brief. 1.02. What is the ratio of the Employment to population ratio(%) in Middle East & North Africa (all income levels) in 1999 to that in 2003?
Your answer should be compact. 1.02. What is the ratio of the Employment to population ratio(%) of Guatemala in 1999 to that in 2003?
Give a very brief answer. 1.01. What is the ratio of the Employment to population ratio(%) of Maldives in 1999 to that in 2003?
Your answer should be compact. 0.99. What is the ratio of the Employment to population ratio(%) of Nepal in 1999 to that in 2003?
Ensure brevity in your answer.  1.01. What is the ratio of the Employment to population ratio(%) of Middle East & North Africa (all income levels) in 1999 to that in 2004?
Your answer should be very brief. 1.01. What is the ratio of the Employment to population ratio(%) of Guatemala in 1999 to that in 2004?
Offer a terse response. 1.01. What is the ratio of the Employment to population ratio(%) in Maldives in 1999 to that in 2004?
Make the answer very short. 0.98. What is the ratio of the Employment to population ratio(%) in Nepal in 1999 to that in 2004?
Make the answer very short. 1.01. What is the ratio of the Employment to population ratio(%) of Maldives in 1999 to that in 2005?
Give a very brief answer. 0.98. What is the ratio of the Employment to population ratio(%) in Nepal in 1999 to that in 2005?
Provide a short and direct response. 1.02. What is the ratio of the Employment to population ratio(%) of Middle East & North Africa (all income levels) in 2000 to that in 2001?
Offer a terse response. 1.01. What is the ratio of the Employment to population ratio(%) of Guatemala in 2000 to that in 2001?
Your answer should be compact. 1. What is the ratio of the Employment to population ratio(%) in Maldives in 2000 to that in 2001?
Offer a very short reply. 1. What is the ratio of the Employment to population ratio(%) in Nepal in 2000 to that in 2001?
Your response must be concise. 1.02. What is the ratio of the Employment to population ratio(%) in Middle East & North Africa (all income levels) in 2000 to that in 2002?
Your answer should be compact. 1.01. What is the ratio of the Employment to population ratio(%) in Guatemala in 2000 to that in 2002?
Offer a very short reply. 1.02. What is the ratio of the Employment to population ratio(%) of Maldives in 2000 to that in 2002?
Keep it short and to the point. 0.99. What is the ratio of the Employment to population ratio(%) in Nepal in 2000 to that in 2002?
Ensure brevity in your answer.  1.01. What is the ratio of the Employment to population ratio(%) in Middle East & North Africa (all income levels) in 2000 to that in 2003?
Give a very brief answer. 1.01. What is the ratio of the Employment to population ratio(%) in Guatemala in 2000 to that in 2003?
Offer a terse response. 1.01. What is the ratio of the Employment to population ratio(%) of Maldives in 2000 to that in 2003?
Your answer should be very brief. 0.99. What is the ratio of the Employment to population ratio(%) of Nepal in 2000 to that in 2003?
Offer a very short reply. 1.01. What is the ratio of the Employment to population ratio(%) of Middle East & North Africa (all income levels) in 2000 to that in 2004?
Your answer should be compact. 1. What is the ratio of the Employment to population ratio(%) in Guatemala in 2000 to that in 2004?
Offer a terse response. 1.02. What is the ratio of the Employment to population ratio(%) in Maldives in 2000 to that in 2004?
Keep it short and to the point. 0.98. What is the ratio of the Employment to population ratio(%) of Middle East & North Africa (all income levels) in 2000 to that in 2005?
Keep it short and to the point. 0.98. What is the ratio of the Employment to population ratio(%) of Guatemala in 2000 to that in 2005?
Provide a short and direct response. 0.99. What is the ratio of the Employment to population ratio(%) of Maldives in 2000 to that in 2005?
Ensure brevity in your answer.  0.97. What is the ratio of the Employment to population ratio(%) of Nepal in 2000 to that in 2005?
Ensure brevity in your answer.  1.01. What is the ratio of the Employment to population ratio(%) of Middle East & North Africa (all income levels) in 2001 to that in 2002?
Your answer should be compact. 1. What is the ratio of the Employment to population ratio(%) in Guatemala in 2001 to that in 2002?
Offer a very short reply. 1.02. What is the ratio of the Employment to population ratio(%) in Maldives in 2001 to that in 2002?
Give a very brief answer. 1. What is the ratio of the Employment to population ratio(%) of Guatemala in 2001 to that in 2003?
Provide a succinct answer. 1.01. What is the ratio of the Employment to population ratio(%) of Middle East & North Africa (all income levels) in 2001 to that in 2004?
Give a very brief answer. 0.99. What is the ratio of the Employment to population ratio(%) of Guatemala in 2001 to that in 2004?
Offer a terse response. 1.02. What is the ratio of the Employment to population ratio(%) in Maldives in 2001 to that in 2004?
Offer a very short reply. 0.98. What is the ratio of the Employment to population ratio(%) in Middle East & North Africa (all income levels) in 2001 to that in 2005?
Offer a very short reply. 0.98. What is the ratio of the Employment to population ratio(%) in Guatemala in 2001 to that in 2005?
Ensure brevity in your answer.  0.99. What is the ratio of the Employment to population ratio(%) in Maldives in 2001 to that in 2005?
Keep it short and to the point. 0.97. What is the ratio of the Employment to population ratio(%) in Nepal in 2001 to that in 2005?
Provide a short and direct response. 1. What is the ratio of the Employment to population ratio(%) of Middle East & North Africa (all income levels) in 2002 to that in 2003?
Your response must be concise. 1. What is the ratio of the Employment to population ratio(%) of Guatemala in 2002 to that in 2003?
Keep it short and to the point. 1. What is the ratio of the Employment to population ratio(%) of Maldives in 2002 to that in 2003?
Offer a very short reply. 0.99. What is the ratio of the Employment to population ratio(%) in Nepal in 2002 to that in 2003?
Provide a succinct answer. 1. What is the ratio of the Employment to population ratio(%) of Middle East & North Africa (all income levels) in 2002 to that in 2004?
Offer a terse response. 0.99. What is the ratio of the Employment to population ratio(%) of Maldives in 2002 to that in 2004?
Your answer should be compact. 0.98. What is the ratio of the Employment to population ratio(%) of Nepal in 2002 to that in 2004?
Ensure brevity in your answer.  1. What is the ratio of the Employment to population ratio(%) of Middle East & North Africa (all income levels) in 2002 to that in 2005?
Provide a succinct answer. 0.98. What is the ratio of the Employment to population ratio(%) of Guatemala in 2002 to that in 2005?
Ensure brevity in your answer.  0.98. What is the ratio of the Employment to population ratio(%) in Maldives in 2002 to that in 2005?
Make the answer very short. 0.98. What is the ratio of the Employment to population ratio(%) of Nepal in 2002 to that in 2005?
Your answer should be compact. 1. What is the ratio of the Employment to population ratio(%) of Middle East & North Africa (all income levels) in 2003 to that in 2004?
Keep it short and to the point. 0.99. What is the ratio of the Employment to population ratio(%) in Maldives in 2003 to that in 2004?
Offer a very short reply. 0.99. What is the ratio of the Employment to population ratio(%) of Middle East & North Africa (all income levels) in 2003 to that in 2005?
Offer a very short reply. 0.97. What is the ratio of the Employment to population ratio(%) of Guatemala in 2003 to that in 2005?
Your response must be concise. 0.98. What is the ratio of the Employment to population ratio(%) of Maldives in 2003 to that in 2005?
Give a very brief answer. 0.98. What is the ratio of the Employment to population ratio(%) in Middle East & North Africa (all income levels) in 2004 to that in 2005?
Give a very brief answer. 0.99. What is the ratio of the Employment to population ratio(%) in Guatemala in 2004 to that in 2005?
Your response must be concise. 0.98. What is the difference between the highest and the second highest Employment to population ratio(%) of Middle East & North Africa (all income levels)?
Give a very brief answer. 0.34. What is the difference between the highest and the lowest Employment to population ratio(%) of Middle East & North Africa (all income levels)?
Provide a short and direct response. 1.75. What is the difference between the highest and the lowest Employment to population ratio(%) in Guatemala?
Ensure brevity in your answer.  2. What is the difference between the highest and the lowest Employment to population ratio(%) in Maldives?
Ensure brevity in your answer.  2.1. 